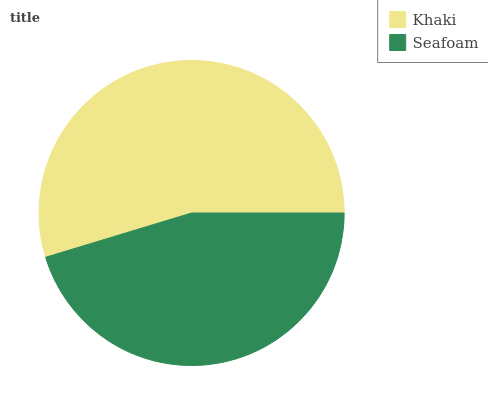Is Seafoam the minimum?
Answer yes or no. Yes. Is Khaki the maximum?
Answer yes or no. Yes. Is Seafoam the maximum?
Answer yes or no. No. Is Khaki greater than Seafoam?
Answer yes or no. Yes. Is Seafoam less than Khaki?
Answer yes or no. Yes. Is Seafoam greater than Khaki?
Answer yes or no. No. Is Khaki less than Seafoam?
Answer yes or no. No. Is Khaki the high median?
Answer yes or no. Yes. Is Seafoam the low median?
Answer yes or no. Yes. Is Seafoam the high median?
Answer yes or no. No. Is Khaki the low median?
Answer yes or no. No. 